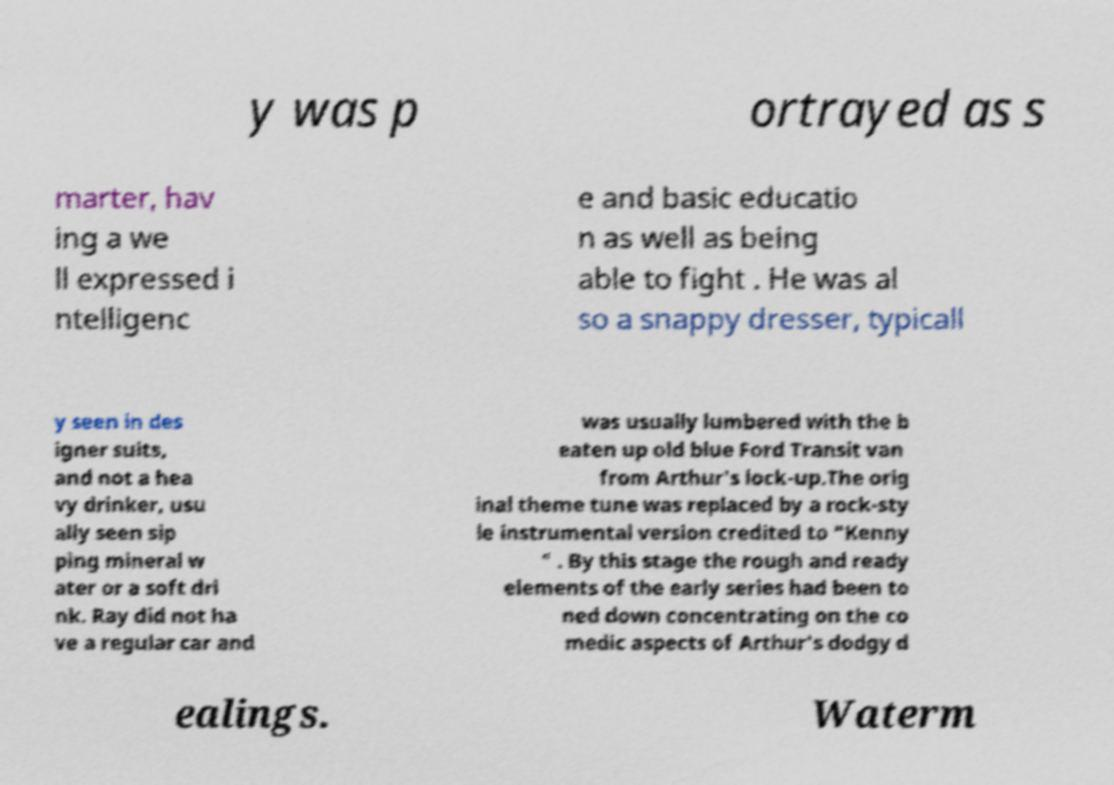I need the written content from this picture converted into text. Can you do that? y was p ortrayed as s marter, hav ing a we ll expressed i ntelligenc e and basic educatio n as well as being able to fight . He was al so a snappy dresser, typicall y seen in des igner suits, and not a hea vy drinker, usu ally seen sip ping mineral w ater or a soft dri nk. Ray did not ha ve a regular car and was usually lumbered with the b eaten up old blue Ford Transit van from Arthur's lock-up.The orig inal theme tune was replaced by a rock-sty le instrumental version credited to "Kenny " . By this stage the rough and ready elements of the early series had been to ned down concentrating on the co medic aspects of Arthur's dodgy d ealings. Waterm 